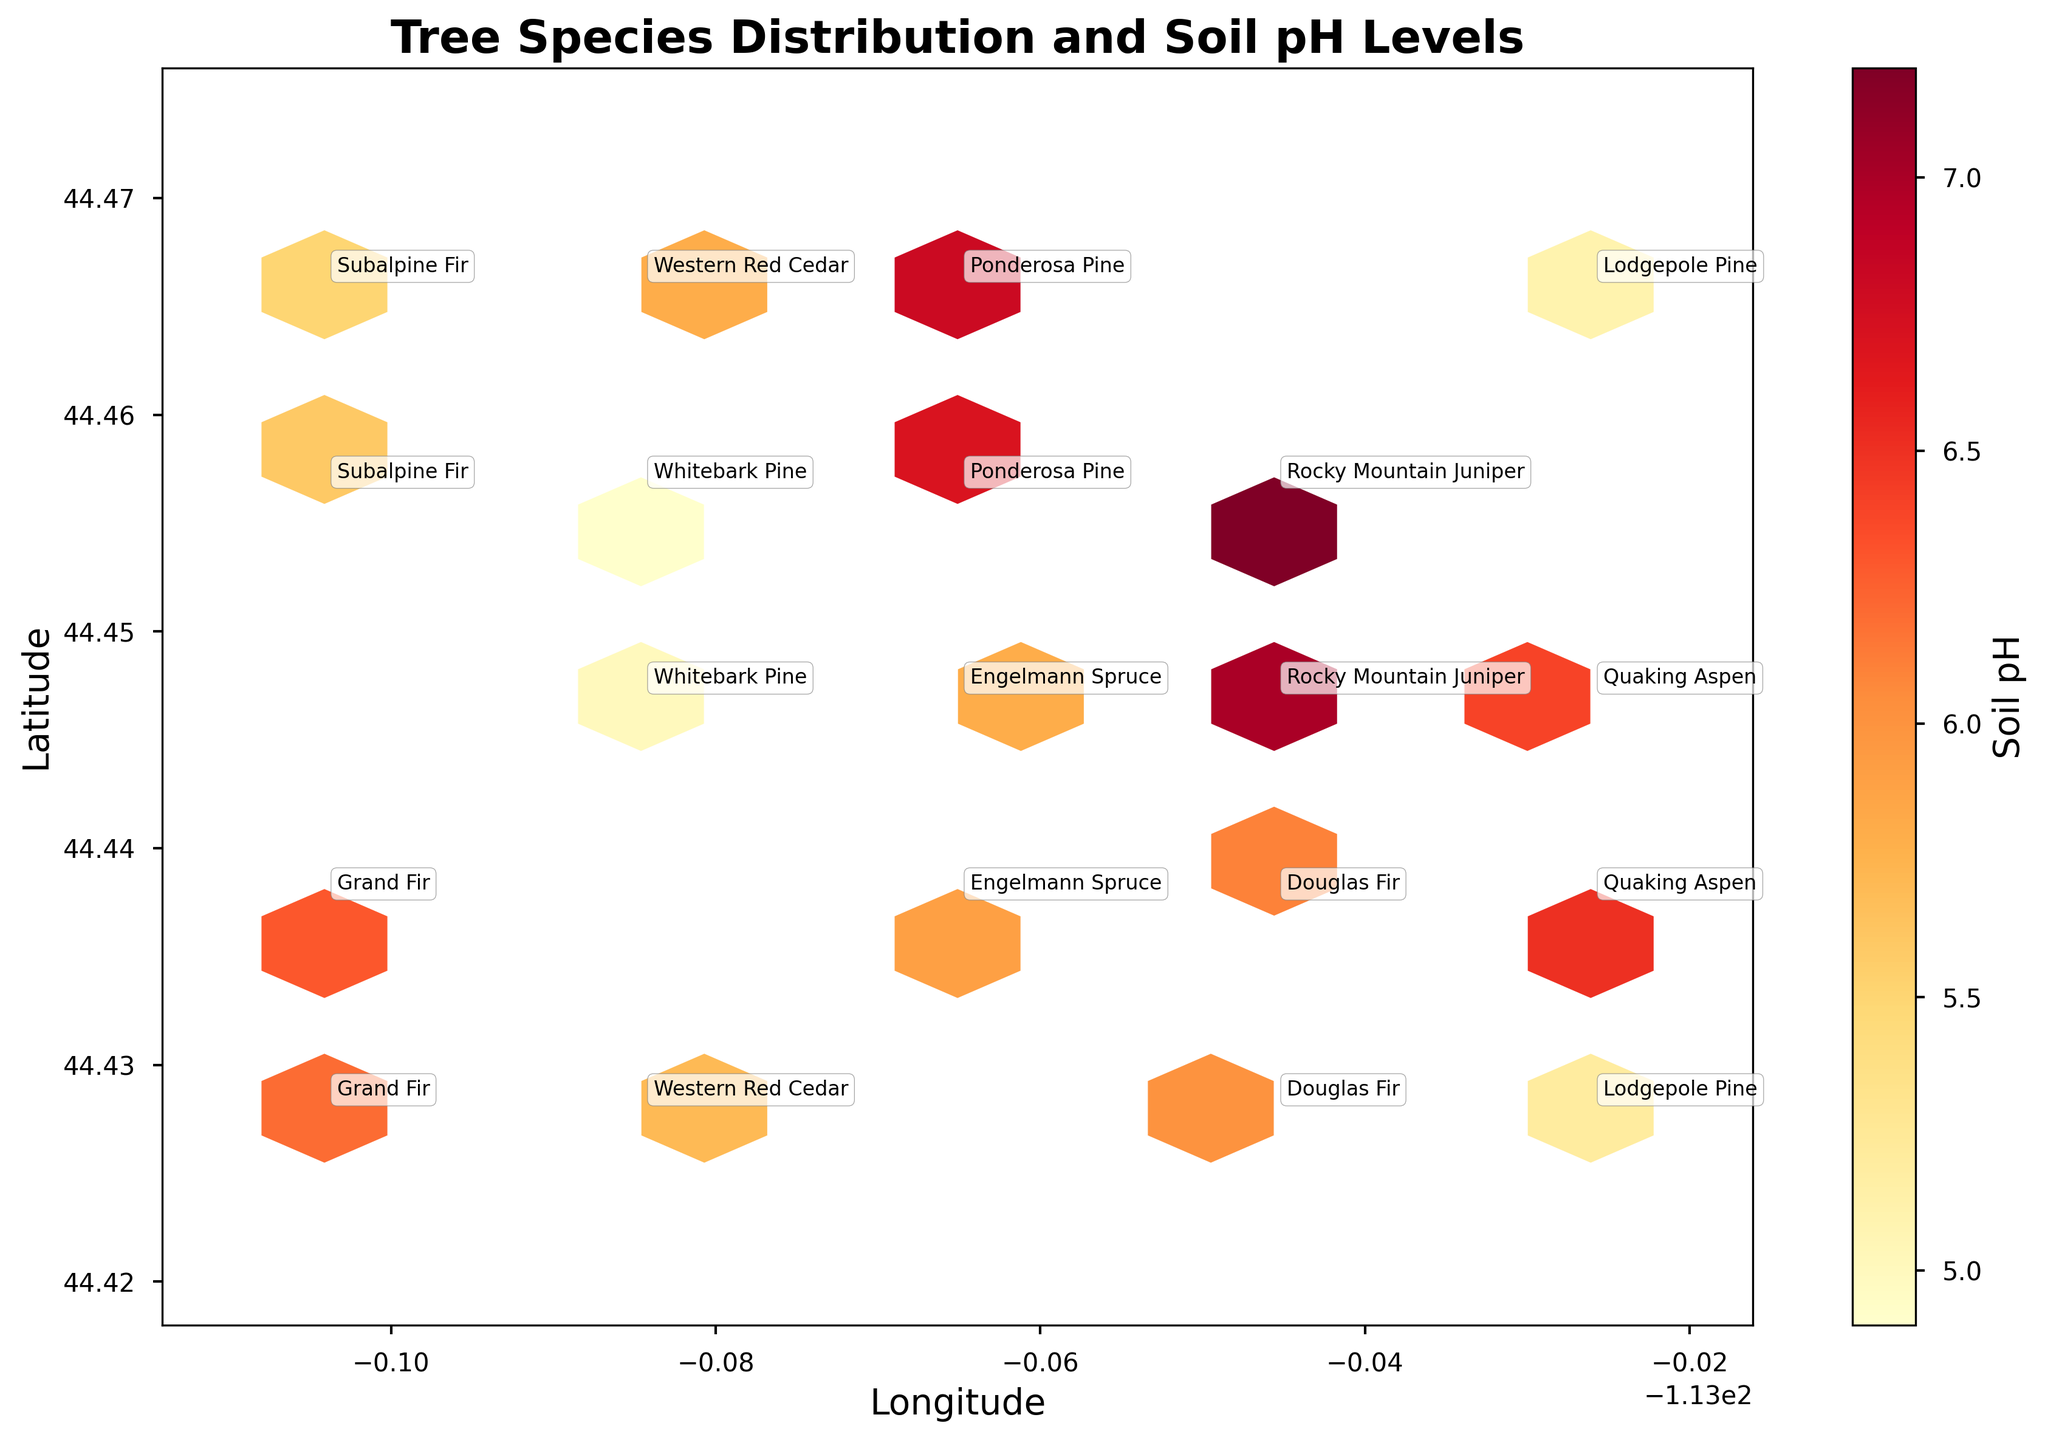What's the title of the figure? The title is usually positioned at the top center of the figure. In this case, it reads 'Tree Species Distribution and Soil pH Levels'.
Answer: Tree Species Distribution and Soil pH Levels What are the axis labels? The labels for the x-axis and y-axis typically describe what those axes represent. Here, the x-axis is labeled 'Longitude' and the y-axis is labeled 'Latitude'.
Answer: Longitude, Latitude What does the color of the hexagons represent? The color represents the soil pH level, as indicated by the color bar on the right side of the figure.
Answer: Soil pH Which tree species is located at the highest latitude? To identify the tree at the highest latitude, look for the point farthest up along the y-axis and check its label.
Answer: Subalpine Fir How many different tree species are annotated in the figure? By counting the unique names labeled on the figure, we find that there are 10 different tree species.
Answer: 10 What tree species is found at the location with the most acidic soil (lowest pH)? Locate the hexagon with the darkest color representing the smallest value on the color bar. Then, identify the species annotated near that hexagon.
Answer: Whitebark Pine Which tree species are found together at exactly 44.4470 latitude? Look for the annotations at the 44.4470 mark on the y-axis and list all species.
Answer: Engelmann Spruce, Whitebark Pine, Quaking Aspen What is the range of soil pH levels represented in the figure? Examine the color bar to see the minimum and maximum values of soil pH levels. The range is from 4.9 to 7.2.
Answer: 4.9 to 7.2 Which tree species is found at multiple locations? Identify species with annotations at more than one unique coordinate. Lodgepole Pine appears at two different locations.
Answer: Lodgepole Pine 